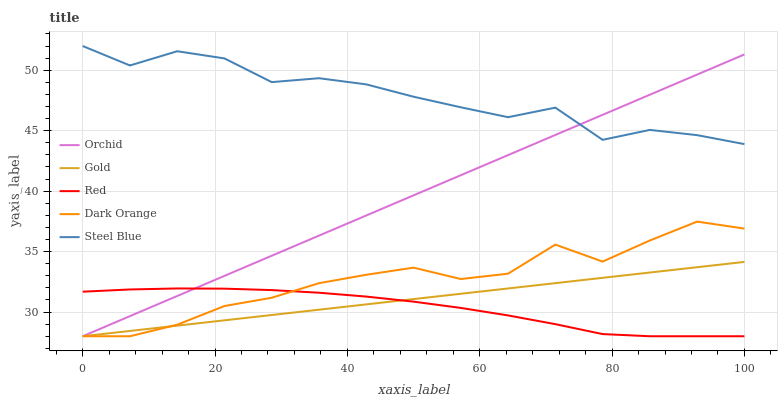Does Red have the minimum area under the curve?
Answer yes or no. Yes. Does Steel Blue have the maximum area under the curve?
Answer yes or no. Yes. Does Steel Blue have the minimum area under the curve?
Answer yes or no. No. Does Red have the maximum area under the curve?
Answer yes or no. No. Is Gold the smoothest?
Answer yes or no. Yes. Is Steel Blue the roughest?
Answer yes or no. Yes. Is Red the smoothest?
Answer yes or no. No. Is Red the roughest?
Answer yes or no. No. Does Dark Orange have the lowest value?
Answer yes or no. Yes. Does Steel Blue have the lowest value?
Answer yes or no. No. Does Steel Blue have the highest value?
Answer yes or no. Yes. Does Red have the highest value?
Answer yes or no. No. Is Gold less than Steel Blue?
Answer yes or no. Yes. Is Steel Blue greater than Gold?
Answer yes or no. Yes. Does Orchid intersect Steel Blue?
Answer yes or no. Yes. Is Orchid less than Steel Blue?
Answer yes or no. No. Is Orchid greater than Steel Blue?
Answer yes or no. No. Does Gold intersect Steel Blue?
Answer yes or no. No. 